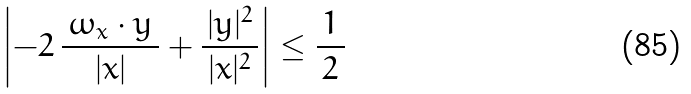Convert formula to latex. <formula><loc_0><loc_0><loc_500><loc_500>\left | - 2 \, \frac { \, \omega _ { x } \cdot y \, } { | x | } + \frac { | y | ^ { 2 } } { \, | x | ^ { 2 } \, } \right | \leq \frac { 1 } { \, 2 \, }</formula> 